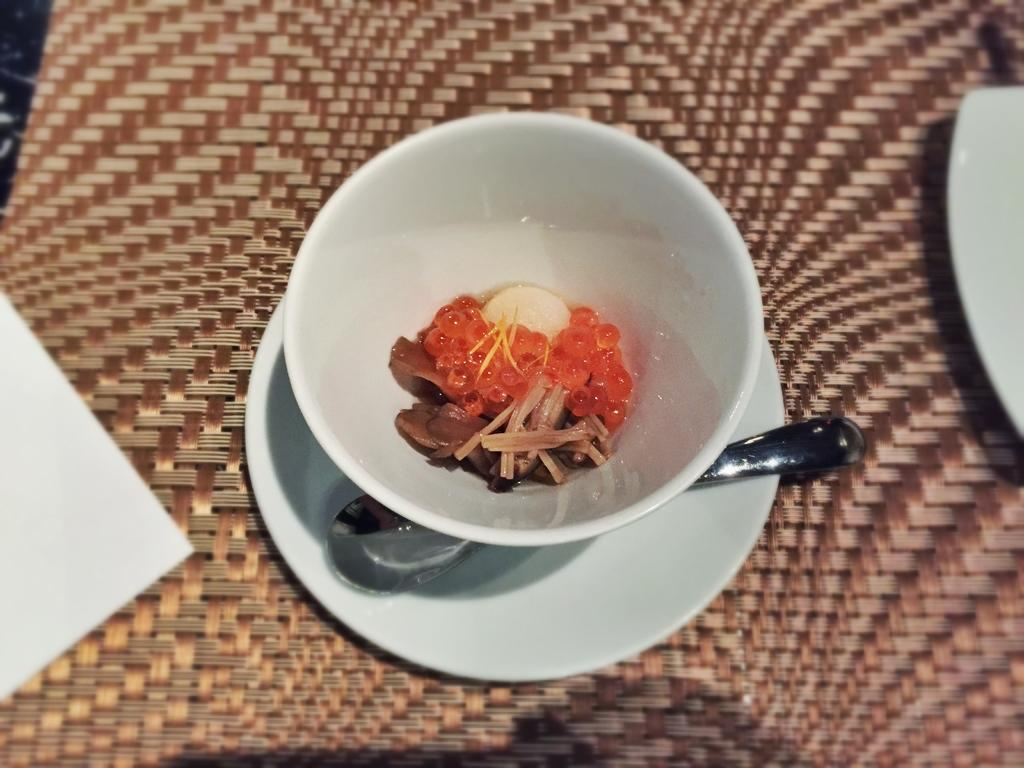What is placed on the table in the image? There is a paper, a plate, a bowl, a saucer, and a spoon on the table. What is inside the bowl on the table? There are food items in the bowl. What type of utensil is present on the table? There is a spoon on the table. Can you see a brush being used to clean the snake in the image? There is no brush or snake present in the image. What type of vegetable is being served on the plate in the image? The provided facts do not mention any vegetables or a plate with food items; only a bowl with food items is mentioned. 